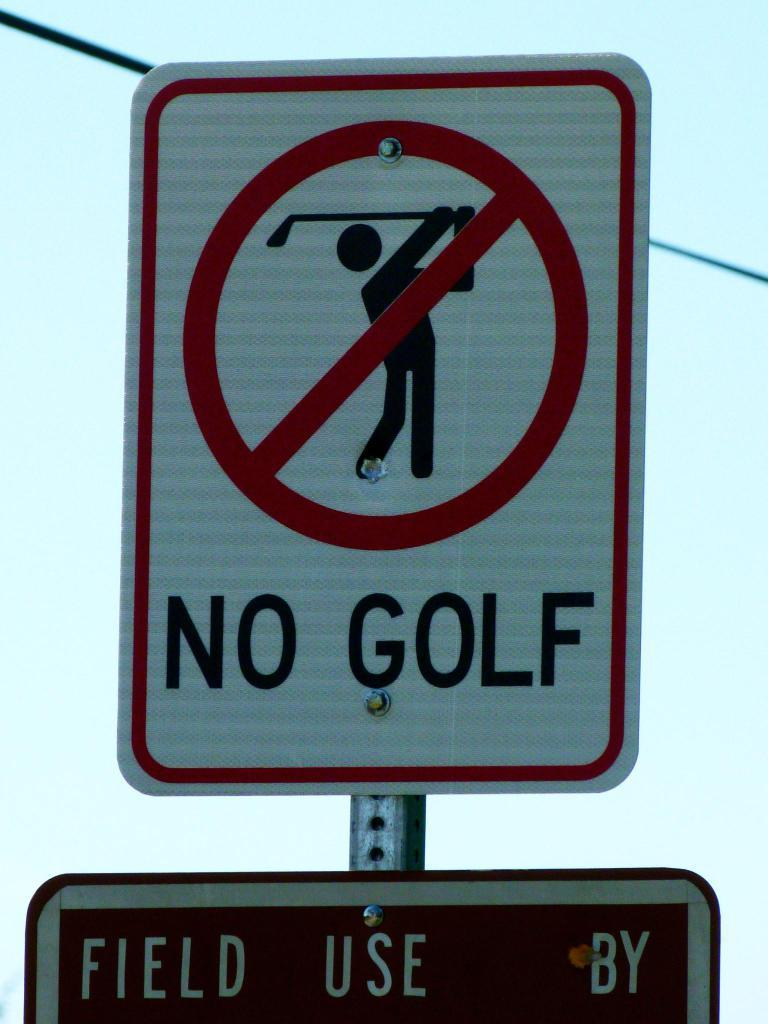<image>
Render a clear and concise summary of the photo. the words no golf that is on a sign 